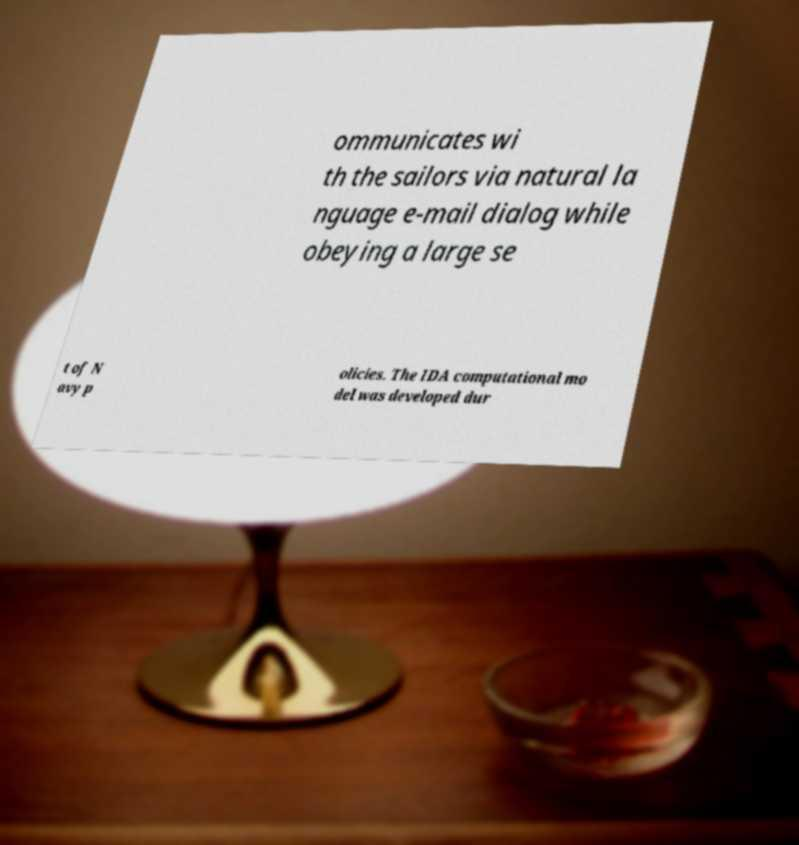Can you read and provide the text displayed in the image?This photo seems to have some interesting text. Can you extract and type it out for me? ommunicates wi th the sailors via natural la nguage e-mail dialog while obeying a large se t of N avy p olicies. The IDA computational mo del was developed dur 